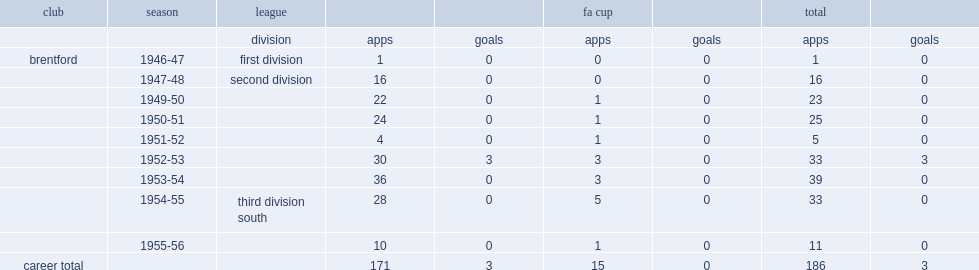How many goals did frank latimer play for the bees totally? 3.0. 